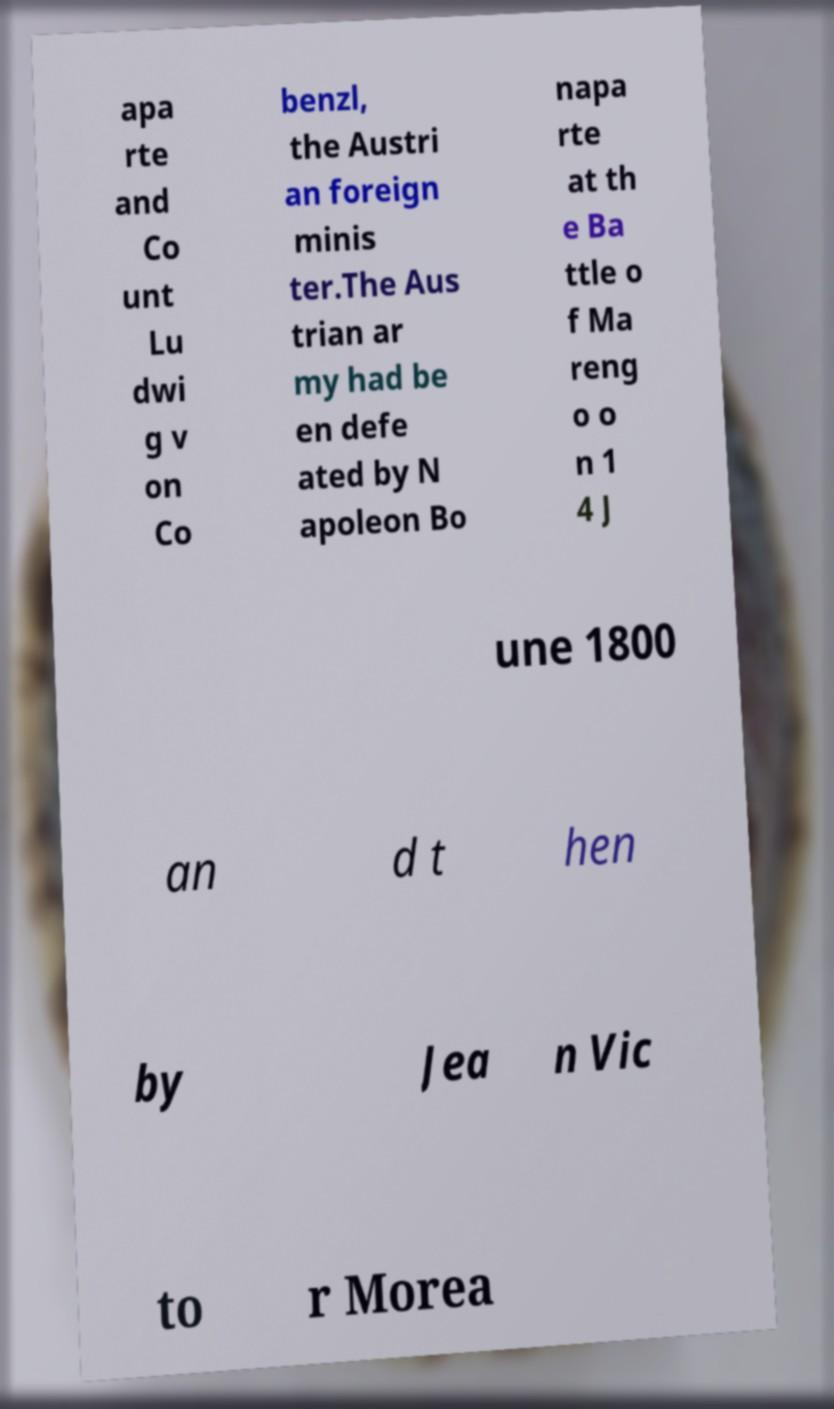Please identify and transcribe the text found in this image. apa rte and Co unt Lu dwi g v on Co benzl, the Austri an foreign minis ter.The Aus trian ar my had be en defe ated by N apoleon Bo napa rte at th e Ba ttle o f Ma reng o o n 1 4 J une 1800 an d t hen by Jea n Vic to r Morea 